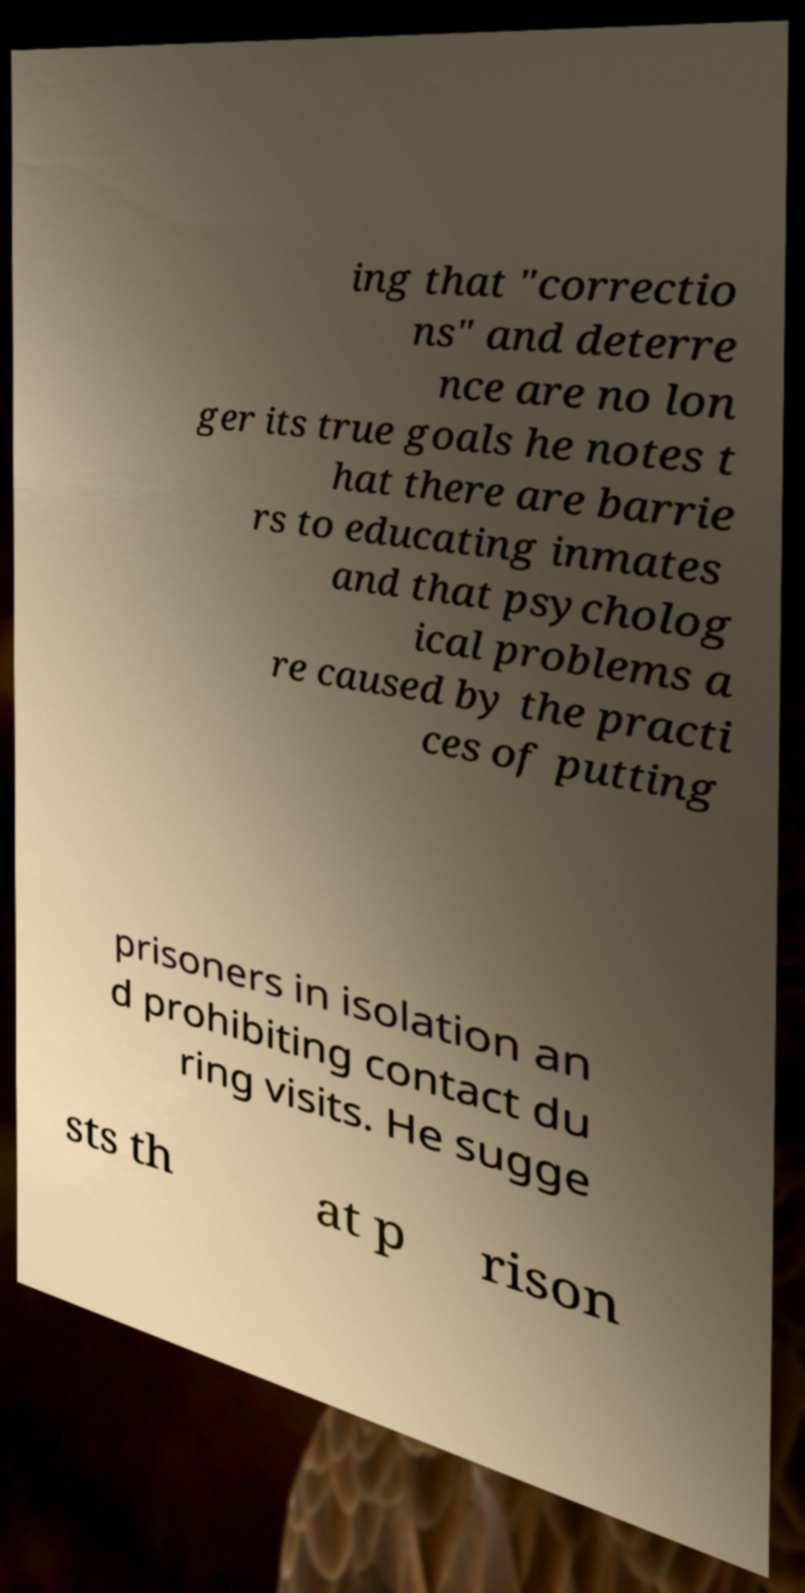There's text embedded in this image that I need extracted. Can you transcribe it verbatim? ing that "correctio ns" and deterre nce are no lon ger its true goals he notes t hat there are barrie rs to educating inmates and that psycholog ical problems a re caused by the practi ces of putting prisoners in isolation an d prohibiting contact du ring visits. He sugge sts th at p rison 